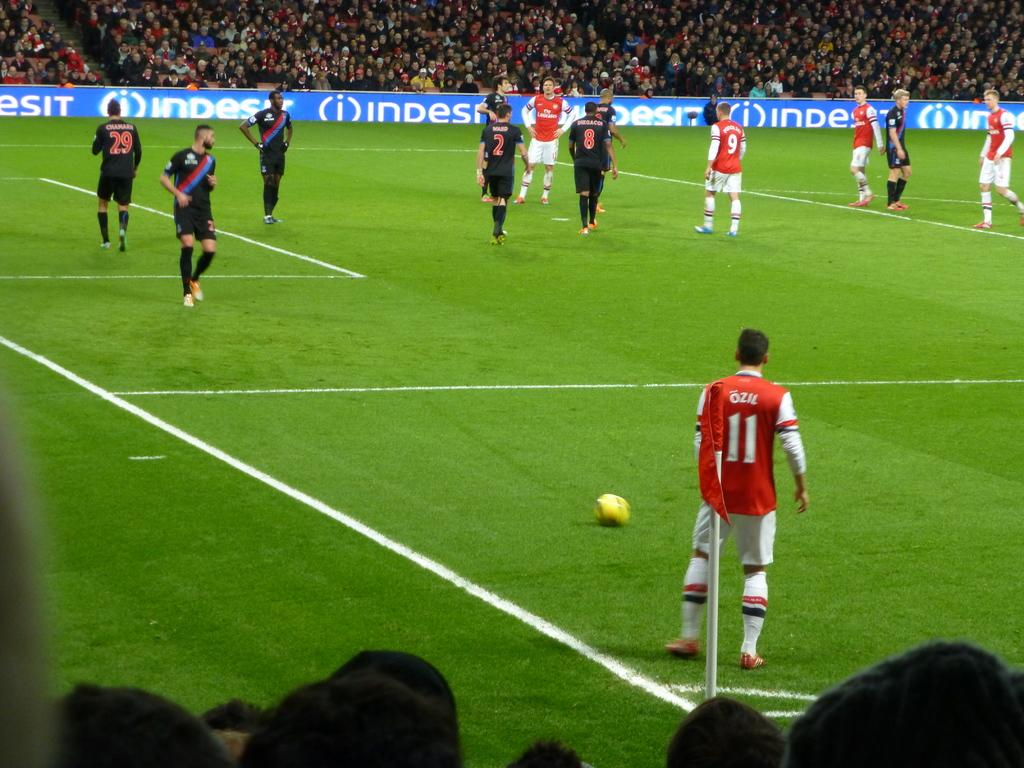<image>
Provide a brief description of the given image. A soccer player in a red shirt with the name OZIL on his shirt on a field with other players 